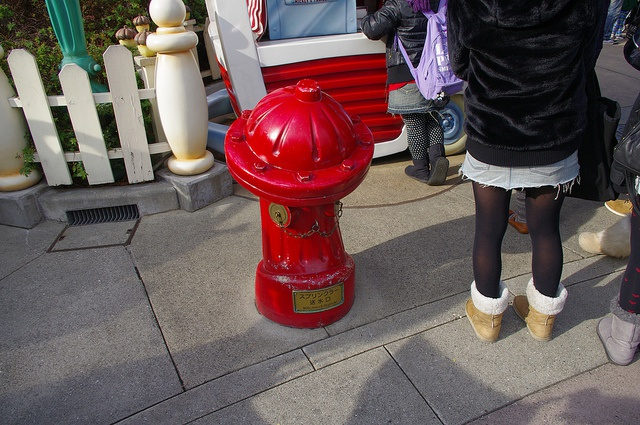Describe the objects in this image and their specific colors. I can see people in black, darkgray, lightgray, and gray tones, fire hydrant in black, brown, and maroon tones, people in black, gray, and darkgray tones, handbag in black, gray, and darkgray tones, and people in black, darkgray, and gray tones in this image. 